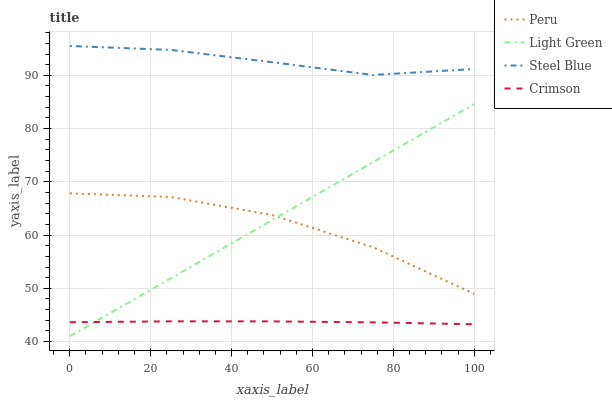Does Crimson have the minimum area under the curve?
Answer yes or no. Yes. Does Steel Blue have the maximum area under the curve?
Answer yes or no. Yes. Does Light Green have the minimum area under the curve?
Answer yes or no. No. Does Light Green have the maximum area under the curve?
Answer yes or no. No. Is Light Green the smoothest?
Answer yes or no. Yes. Is Peru the roughest?
Answer yes or no. Yes. Is Peru the smoothest?
Answer yes or no. No. Is Light Green the roughest?
Answer yes or no. No. Does Light Green have the lowest value?
Answer yes or no. Yes. Does Peru have the lowest value?
Answer yes or no. No. Does Steel Blue have the highest value?
Answer yes or no. Yes. Does Light Green have the highest value?
Answer yes or no. No. Is Peru less than Steel Blue?
Answer yes or no. Yes. Is Steel Blue greater than Light Green?
Answer yes or no. Yes. Does Light Green intersect Peru?
Answer yes or no. Yes. Is Light Green less than Peru?
Answer yes or no. No. Is Light Green greater than Peru?
Answer yes or no. No. Does Peru intersect Steel Blue?
Answer yes or no. No. 